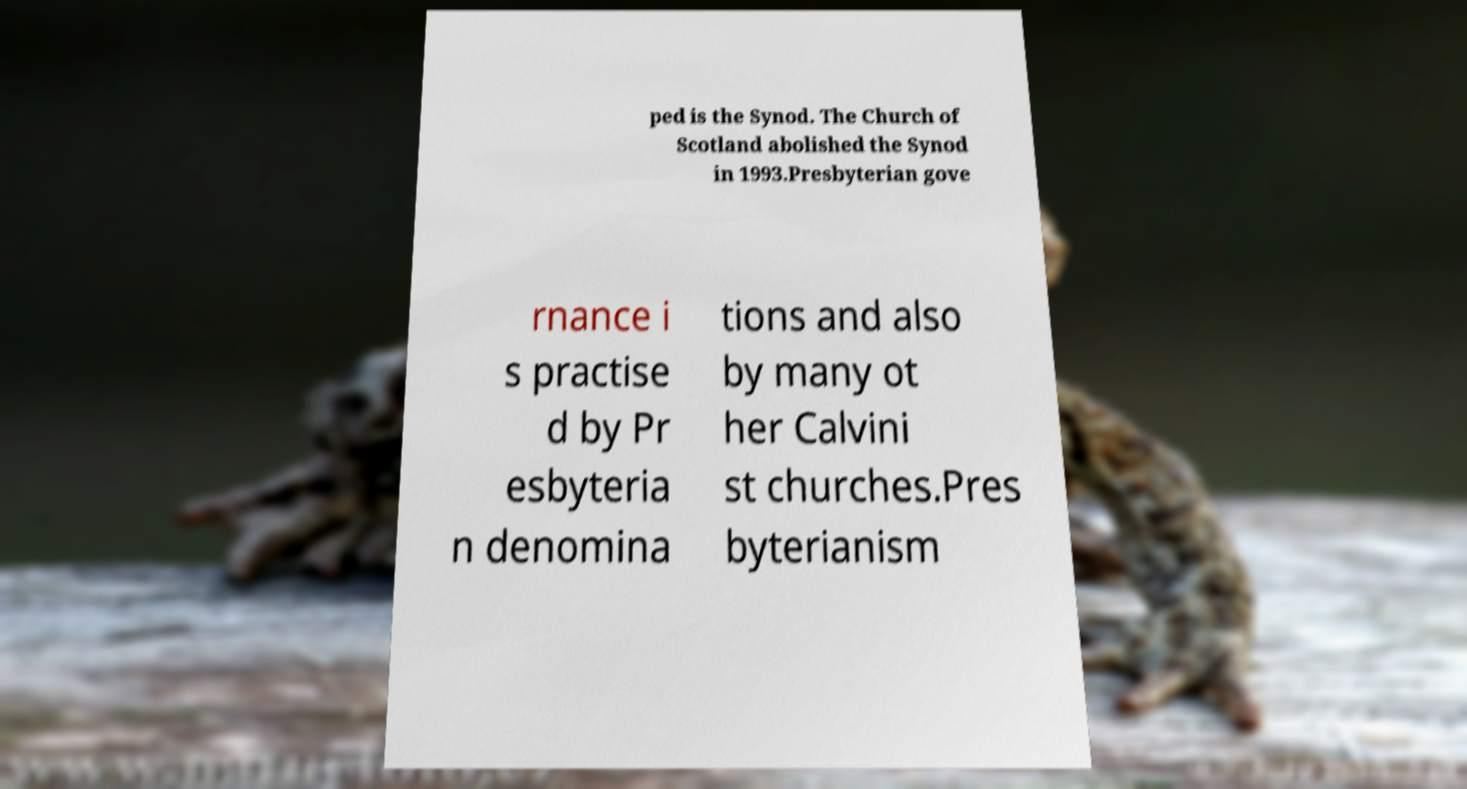Could you extract and type out the text from this image? ped is the Synod. The Church of Scotland abolished the Synod in 1993.Presbyterian gove rnance i s practise d by Pr esbyteria n denomina tions and also by many ot her Calvini st churches.Pres byterianism 